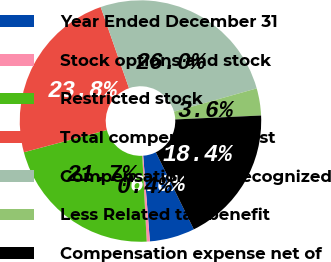<chart> <loc_0><loc_0><loc_500><loc_500><pie_chart><fcel>Year Ended December 31<fcel>Stock options and stock<fcel>Restricted stock<fcel>Total compensation cost<fcel>Compensation cost recognized<fcel>Less Related tax benefit<fcel>Compensation expense net of<nl><fcel>6.04%<fcel>0.42%<fcel>21.66%<fcel>23.82%<fcel>25.99%<fcel>3.63%<fcel>18.45%<nl></chart> 